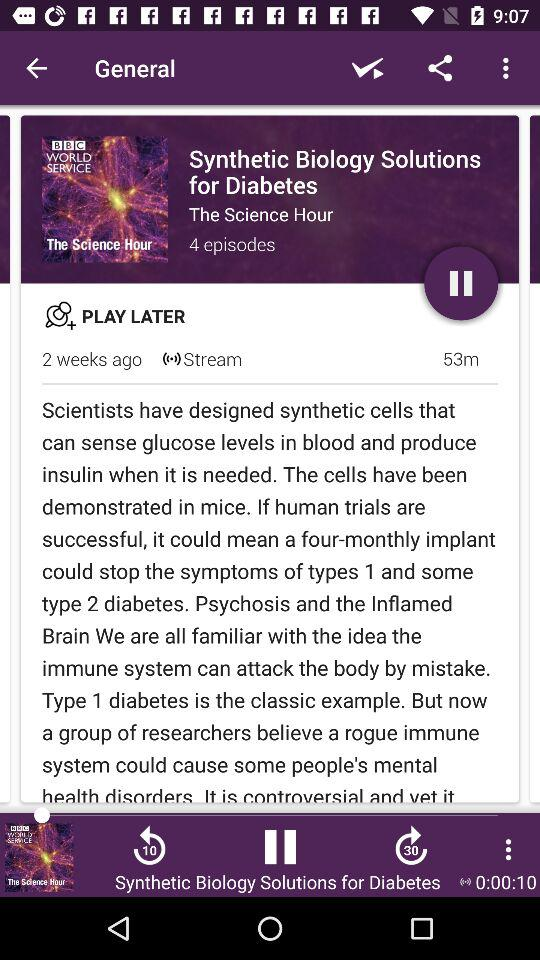How many episodes are there in the series 'The Science Hour'?
Answer the question using a single word or phrase. 4 